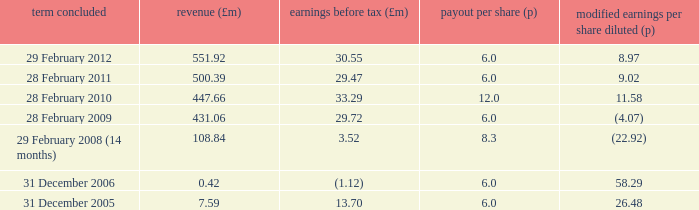What was the turnover when the profit before tax was 29.47? 500.39. 